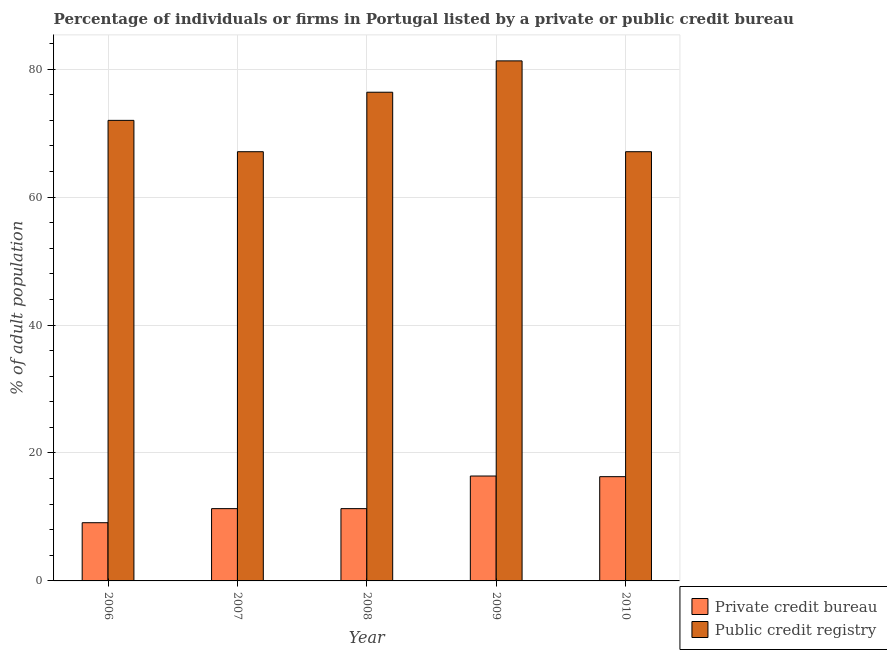Are the number of bars per tick equal to the number of legend labels?
Keep it short and to the point. Yes. Are the number of bars on each tick of the X-axis equal?
Your response must be concise. Yes. How many bars are there on the 5th tick from the right?
Provide a short and direct response. 2. What is the label of the 4th group of bars from the left?
Your answer should be very brief. 2009. What is the percentage of firms listed by private credit bureau in 2007?
Provide a succinct answer. 11.3. Across all years, what is the maximum percentage of firms listed by public credit bureau?
Your answer should be compact. 81.3. Across all years, what is the minimum percentage of firms listed by public credit bureau?
Your answer should be very brief. 67.1. What is the total percentage of firms listed by private credit bureau in the graph?
Your response must be concise. 64.4. What is the difference between the percentage of firms listed by public credit bureau in 2006 and that in 2008?
Provide a short and direct response. -4.4. What is the difference between the percentage of firms listed by public credit bureau in 2008 and the percentage of firms listed by private credit bureau in 2007?
Ensure brevity in your answer.  9.3. What is the average percentage of firms listed by private credit bureau per year?
Provide a succinct answer. 12.88. In the year 2008, what is the difference between the percentage of firms listed by public credit bureau and percentage of firms listed by private credit bureau?
Ensure brevity in your answer.  0. What is the ratio of the percentage of firms listed by private credit bureau in 2006 to that in 2009?
Offer a terse response. 0.55. Is the percentage of firms listed by private credit bureau in 2007 less than that in 2008?
Keep it short and to the point. No. Is the difference between the percentage of firms listed by public credit bureau in 2008 and 2009 greater than the difference between the percentage of firms listed by private credit bureau in 2008 and 2009?
Provide a succinct answer. No. What is the difference between the highest and the second highest percentage of firms listed by private credit bureau?
Offer a very short reply. 0.1. What is the difference between the highest and the lowest percentage of firms listed by private credit bureau?
Your answer should be very brief. 7.3. In how many years, is the percentage of firms listed by public credit bureau greater than the average percentage of firms listed by public credit bureau taken over all years?
Keep it short and to the point. 2. Is the sum of the percentage of firms listed by public credit bureau in 2006 and 2007 greater than the maximum percentage of firms listed by private credit bureau across all years?
Make the answer very short. Yes. What does the 1st bar from the left in 2008 represents?
Ensure brevity in your answer.  Private credit bureau. What does the 1st bar from the right in 2010 represents?
Your answer should be compact. Public credit registry. Are all the bars in the graph horizontal?
Make the answer very short. No. Does the graph contain grids?
Make the answer very short. Yes. How are the legend labels stacked?
Offer a very short reply. Vertical. What is the title of the graph?
Your answer should be very brief. Percentage of individuals or firms in Portugal listed by a private or public credit bureau. What is the label or title of the Y-axis?
Ensure brevity in your answer.  % of adult population. What is the % of adult population of Public credit registry in 2006?
Provide a short and direct response. 72. What is the % of adult population of Private credit bureau in 2007?
Provide a succinct answer. 11.3. What is the % of adult population of Public credit registry in 2007?
Offer a very short reply. 67.1. What is the % of adult population of Private credit bureau in 2008?
Ensure brevity in your answer.  11.3. What is the % of adult population in Public credit registry in 2008?
Ensure brevity in your answer.  76.4. What is the % of adult population in Public credit registry in 2009?
Your response must be concise. 81.3. What is the % of adult population of Public credit registry in 2010?
Your answer should be very brief. 67.1. Across all years, what is the maximum % of adult population of Public credit registry?
Make the answer very short. 81.3. Across all years, what is the minimum % of adult population of Private credit bureau?
Your response must be concise. 9.1. Across all years, what is the minimum % of adult population of Public credit registry?
Your answer should be compact. 67.1. What is the total % of adult population in Private credit bureau in the graph?
Give a very brief answer. 64.4. What is the total % of adult population in Public credit registry in the graph?
Make the answer very short. 363.9. What is the difference between the % of adult population of Private credit bureau in 2006 and that in 2007?
Ensure brevity in your answer.  -2.2. What is the difference between the % of adult population in Public credit registry in 2006 and that in 2008?
Your answer should be compact. -4.4. What is the difference between the % of adult population of Private credit bureau in 2006 and that in 2009?
Provide a succinct answer. -7.3. What is the difference between the % of adult population in Public credit registry in 2006 and that in 2009?
Provide a succinct answer. -9.3. What is the difference between the % of adult population in Private credit bureau in 2006 and that in 2010?
Make the answer very short. -7.2. What is the difference between the % of adult population of Private credit bureau in 2007 and that in 2009?
Your answer should be very brief. -5.1. What is the difference between the % of adult population of Public credit registry in 2007 and that in 2009?
Your answer should be compact. -14.2. What is the difference between the % of adult population in Private credit bureau in 2007 and that in 2010?
Offer a terse response. -5. What is the difference between the % of adult population of Public credit registry in 2008 and that in 2009?
Keep it short and to the point. -4.9. What is the difference between the % of adult population in Public credit registry in 2008 and that in 2010?
Offer a very short reply. 9.3. What is the difference between the % of adult population of Private credit bureau in 2009 and that in 2010?
Make the answer very short. 0.1. What is the difference between the % of adult population of Public credit registry in 2009 and that in 2010?
Provide a succinct answer. 14.2. What is the difference between the % of adult population of Private credit bureau in 2006 and the % of adult population of Public credit registry in 2007?
Your answer should be compact. -58. What is the difference between the % of adult population of Private credit bureau in 2006 and the % of adult population of Public credit registry in 2008?
Ensure brevity in your answer.  -67.3. What is the difference between the % of adult population in Private credit bureau in 2006 and the % of adult population in Public credit registry in 2009?
Provide a succinct answer. -72.2. What is the difference between the % of adult population in Private credit bureau in 2006 and the % of adult population in Public credit registry in 2010?
Offer a very short reply. -58. What is the difference between the % of adult population of Private credit bureau in 2007 and the % of adult population of Public credit registry in 2008?
Your response must be concise. -65.1. What is the difference between the % of adult population in Private credit bureau in 2007 and the % of adult population in Public credit registry in 2009?
Your response must be concise. -70. What is the difference between the % of adult population of Private credit bureau in 2007 and the % of adult population of Public credit registry in 2010?
Your answer should be very brief. -55.8. What is the difference between the % of adult population of Private credit bureau in 2008 and the % of adult population of Public credit registry in 2009?
Make the answer very short. -70. What is the difference between the % of adult population in Private credit bureau in 2008 and the % of adult population in Public credit registry in 2010?
Offer a terse response. -55.8. What is the difference between the % of adult population of Private credit bureau in 2009 and the % of adult population of Public credit registry in 2010?
Make the answer very short. -50.7. What is the average % of adult population in Private credit bureau per year?
Your response must be concise. 12.88. What is the average % of adult population of Public credit registry per year?
Offer a very short reply. 72.78. In the year 2006, what is the difference between the % of adult population of Private credit bureau and % of adult population of Public credit registry?
Your answer should be compact. -62.9. In the year 2007, what is the difference between the % of adult population in Private credit bureau and % of adult population in Public credit registry?
Give a very brief answer. -55.8. In the year 2008, what is the difference between the % of adult population in Private credit bureau and % of adult population in Public credit registry?
Your answer should be very brief. -65.1. In the year 2009, what is the difference between the % of adult population of Private credit bureau and % of adult population of Public credit registry?
Keep it short and to the point. -64.9. In the year 2010, what is the difference between the % of adult population of Private credit bureau and % of adult population of Public credit registry?
Ensure brevity in your answer.  -50.8. What is the ratio of the % of adult population in Private credit bureau in 2006 to that in 2007?
Keep it short and to the point. 0.81. What is the ratio of the % of adult population in Public credit registry in 2006 to that in 2007?
Offer a very short reply. 1.07. What is the ratio of the % of adult population of Private credit bureau in 2006 to that in 2008?
Provide a short and direct response. 0.81. What is the ratio of the % of adult population of Public credit registry in 2006 to that in 2008?
Make the answer very short. 0.94. What is the ratio of the % of adult population of Private credit bureau in 2006 to that in 2009?
Your answer should be very brief. 0.55. What is the ratio of the % of adult population of Public credit registry in 2006 to that in 2009?
Keep it short and to the point. 0.89. What is the ratio of the % of adult population in Private credit bureau in 2006 to that in 2010?
Ensure brevity in your answer.  0.56. What is the ratio of the % of adult population in Public credit registry in 2006 to that in 2010?
Make the answer very short. 1.07. What is the ratio of the % of adult population of Public credit registry in 2007 to that in 2008?
Provide a short and direct response. 0.88. What is the ratio of the % of adult population in Private credit bureau in 2007 to that in 2009?
Your answer should be compact. 0.69. What is the ratio of the % of adult population in Public credit registry in 2007 to that in 2009?
Your response must be concise. 0.83. What is the ratio of the % of adult population of Private credit bureau in 2007 to that in 2010?
Offer a very short reply. 0.69. What is the ratio of the % of adult population in Private credit bureau in 2008 to that in 2009?
Offer a very short reply. 0.69. What is the ratio of the % of adult population in Public credit registry in 2008 to that in 2009?
Keep it short and to the point. 0.94. What is the ratio of the % of adult population in Private credit bureau in 2008 to that in 2010?
Offer a very short reply. 0.69. What is the ratio of the % of adult population in Public credit registry in 2008 to that in 2010?
Ensure brevity in your answer.  1.14. What is the ratio of the % of adult population of Private credit bureau in 2009 to that in 2010?
Ensure brevity in your answer.  1.01. What is the ratio of the % of adult population of Public credit registry in 2009 to that in 2010?
Provide a short and direct response. 1.21. What is the difference between the highest and the second highest % of adult population of Private credit bureau?
Keep it short and to the point. 0.1. What is the difference between the highest and the lowest % of adult population in Private credit bureau?
Ensure brevity in your answer.  7.3. What is the difference between the highest and the lowest % of adult population in Public credit registry?
Give a very brief answer. 14.2. 